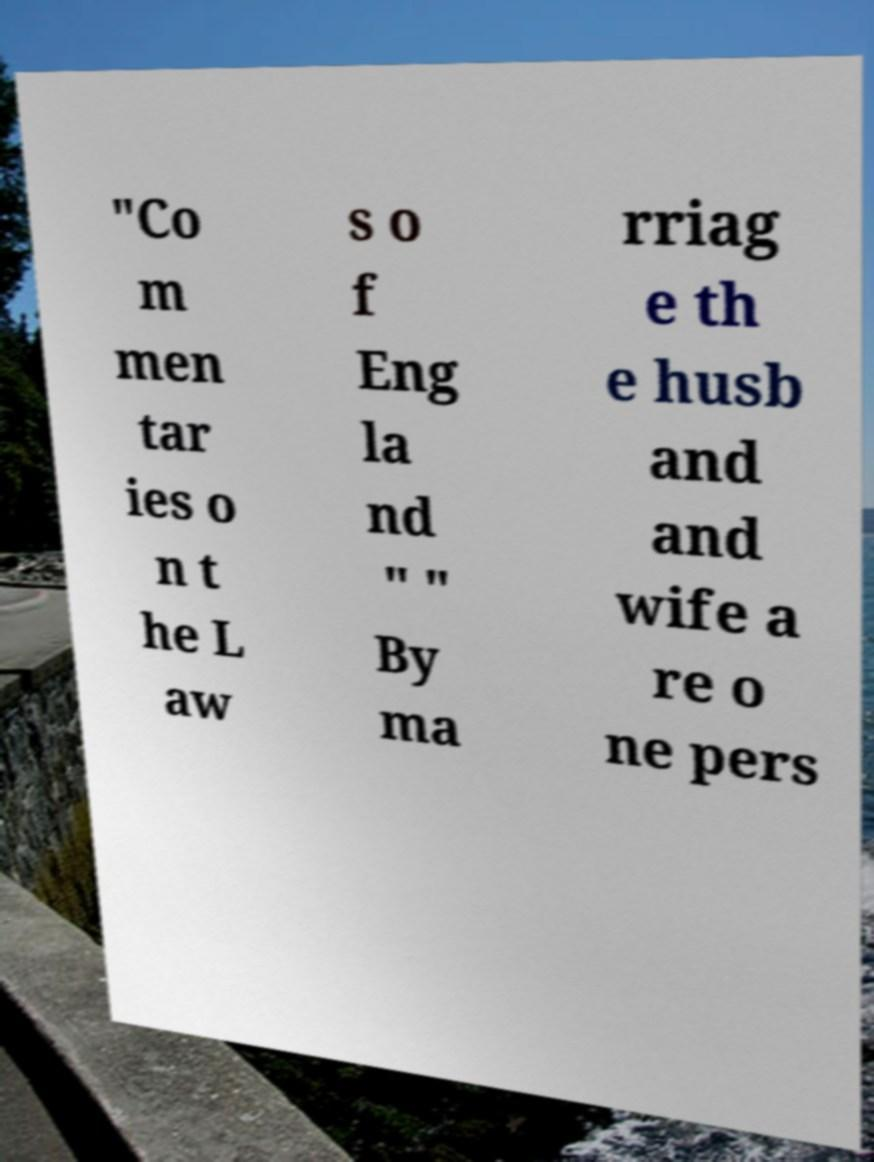Could you extract and type out the text from this image? "Co m men tar ies o n t he L aw s o f Eng la nd " " By ma rriag e th e husb and and wife a re o ne pers 